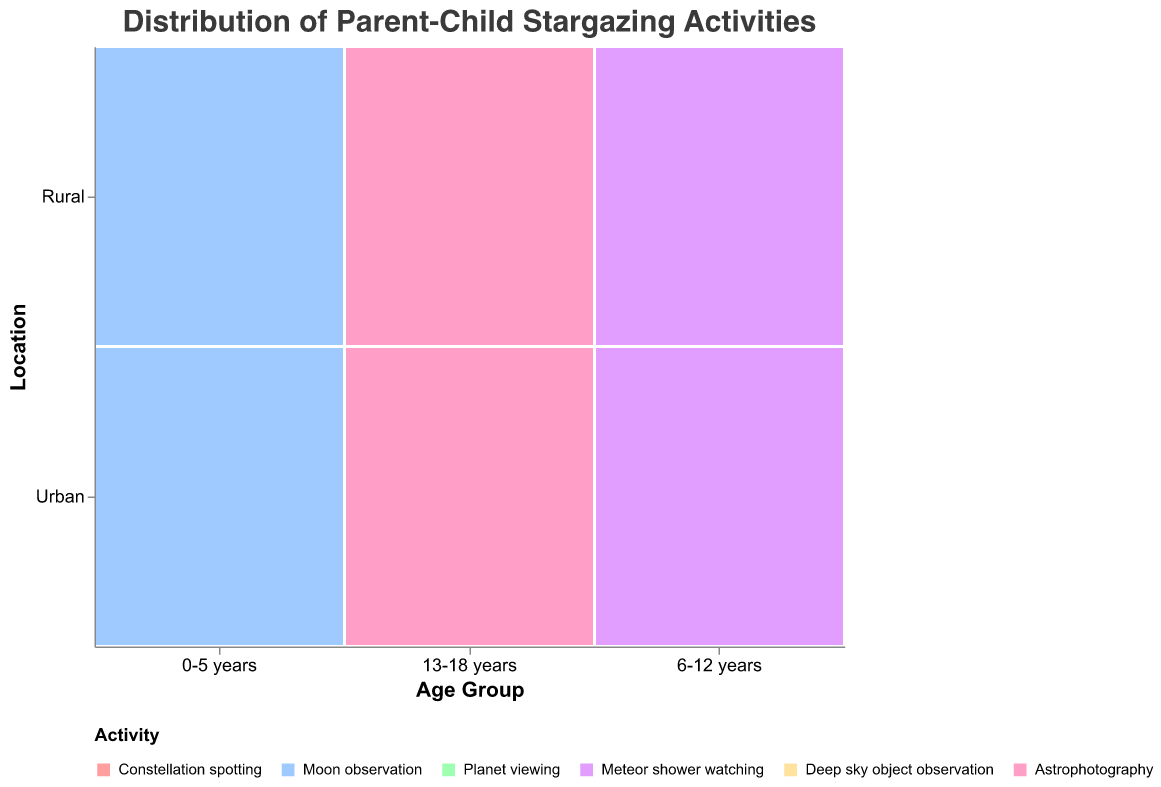What's the most common activity for children aged 0-5 years in rural locations? Look for the "0-5 years" age group in the rural locations row, and identify the activity with the highest frequency. "Moon observation" has a frequency of 38, which is higher than "Constellation spotting" with 22.
Answer: Moon observation How does the frequency of Moon observation in rural areas compare between the 0-5 years and 13-18 years age groups? Identify "Moon observation" in rural locations for the age groups "0-5 years" and "13-18 years". The frequency for 0-5 years is 38, whereas for 13-18 years, Moon observation is not present. Therefore, for 13-18 years, the frequency is 0. So, 38 - 0 = 38.
Answer: 38 more Which age group in urban locations has the lowest frequency for Deep sky object observation? Look at the urban locations row for each age group and find the frequency of "Deep sky object observation". For the age group 13-18 years, the frequency is 12. No other age group in urban locations has this activity.
Answer: 13-18 years Is there a significant difference in activities between 6-12 years rural and urban groups? Compare the activities and their frequencies between rural and urban locations for the 6-12 years group. Rural areas have "Planet viewing" (35), "Meteor shower watching" (25). Urban areas have "Planet viewing" (28), "Meteor shower watching" (18). Calculating the differences: 35 - 28 = 7 for Planet viewing, and 25 - 18 = 7 for Meteor shower watching. Both differences are 7.
Answer: Yes, for two activities How do frequencies of Astrophotography compare between urban and rural locations for the 13-18 years age group? Find the frequency of "Astrophotography" for the 13-18 years age group in urban and rural locations. In urban areas, it is 8. In rural areas, it is 15. The difference is 15 - 8 = 7.
Answer: Higher by 7 in rural Which activity is equally popular in the 6-12 years age group across urban and rural locations? Look at the frequencies of each activity within the 6-12 years age group for urban and rural locations and find any matches. Both "Planet viewing" (28 urban, 35 rural) and "Meteor shower watching" (18 urban, 25 rural) do not have equal frequencies. There are no activities with equal popularity.
Answer: None What activities are missing from the 0-5 years age group in urban locations? Identify all activities by their color and legend. For "0-5 years" in urban locations, only "Constellation spotting" and "Moon observation" are present. Other activities like "Planet viewing," "Meteor shower watching," "Deep sky object observation," and "Astrophotography" are absent.
Answer: Planet viewing, Meteor shower watching, Deep sky object observation, Astrophotography 